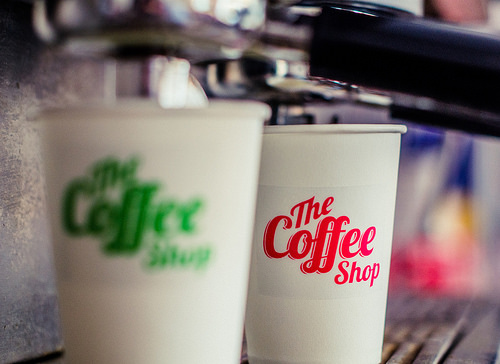<image>
Is there a coffee cup behind the coffee cup? Yes. From this viewpoint, the coffee cup is positioned behind the coffee cup, with the coffee cup partially or fully occluding the coffee cup. 